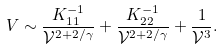<formula> <loc_0><loc_0><loc_500><loc_500>V \sim \frac { K ^ { - 1 } _ { 1 1 } } { \mathcal { V } ^ { 2 + 2 / \gamma } } + \frac { K ^ { - 1 } _ { 2 2 } } { \mathcal { V } ^ { 2 + 2 / \gamma } } + \frac { 1 } { \mathcal { V } ^ { 3 } } .</formula> 